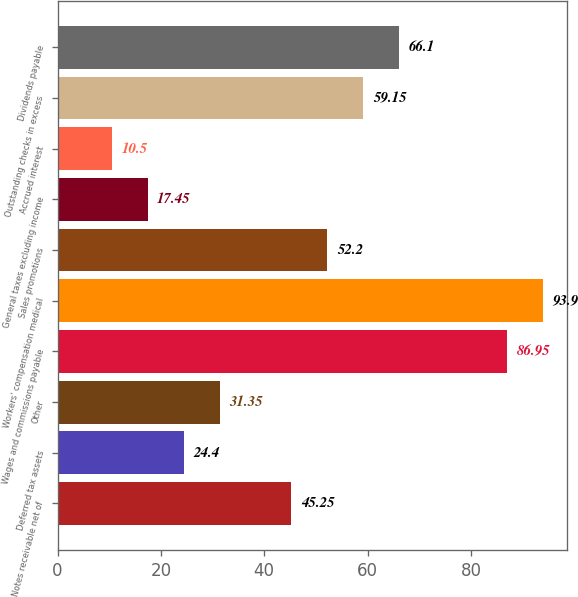Convert chart to OTSL. <chart><loc_0><loc_0><loc_500><loc_500><bar_chart><fcel>Notes receivable net of<fcel>Deferred tax assets<fcel>Other<fcel>Wages and commissions payable<fcel>Workers' compensation medical<fcel>Sales promotions<fcel>General taxes excluding income<fcel>Accrued interest<fcel>Outstanding checks in excess<fcel>Dividends payable<nl><fcel>45.25<fcel>24.4<fcel>31.35<fcel>86.95<fcel>93.9<fcel>52.2<fcel>17.45<fcel>10.5<fcel>59.15<fcel>66.1<nl></chart> 